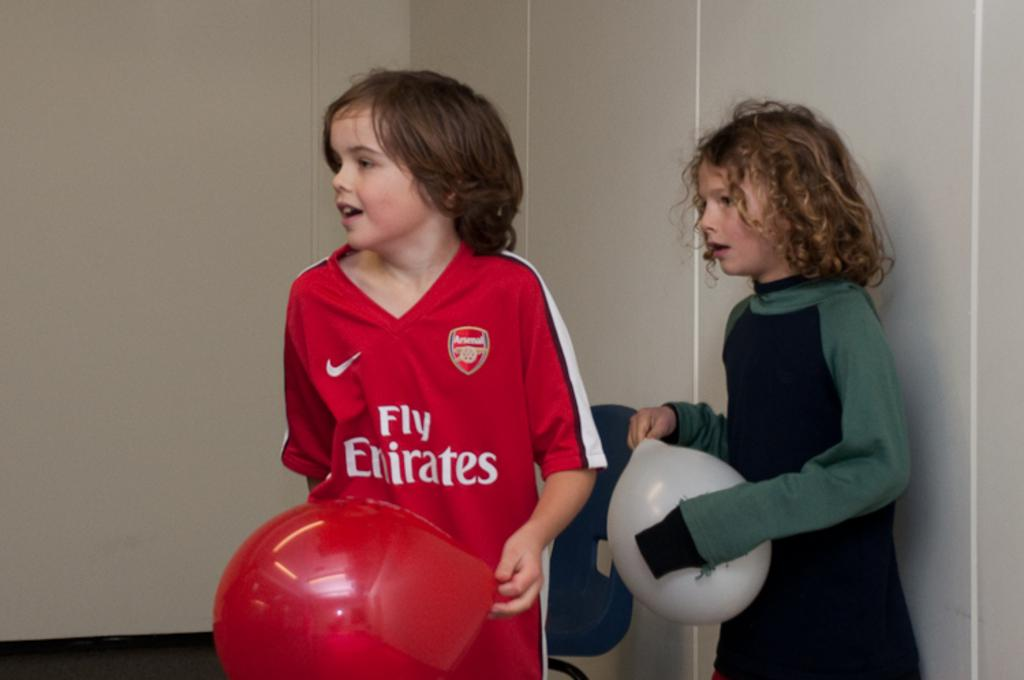<image>
Present a compact description of the photo's key features. a couple people and one with fly emirates on it 